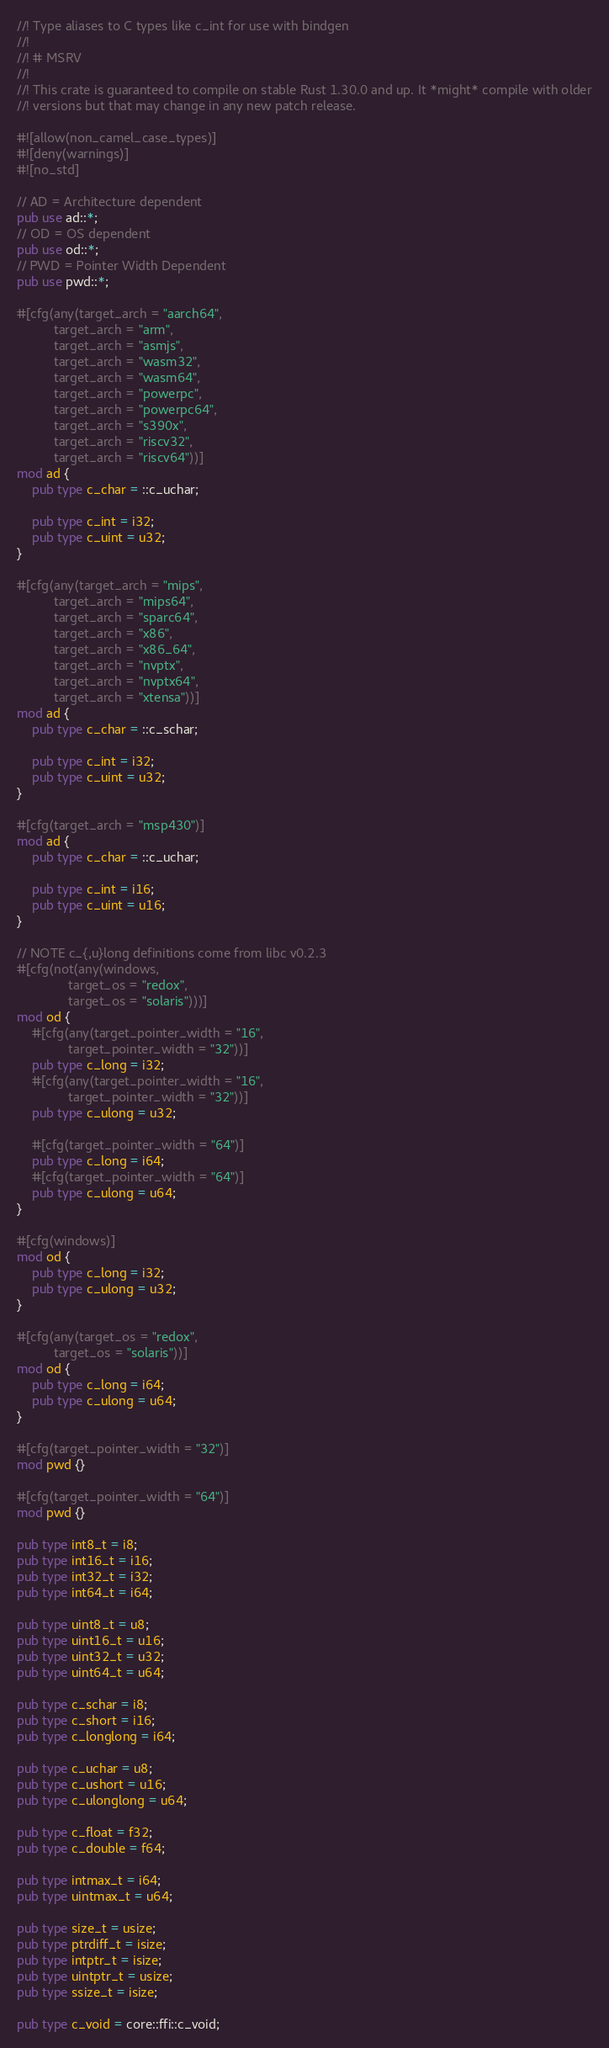Convert code to text. <code><loc_0><loc_0><loc_500><loc_500><_Rust_>//! Type aliases to C types like c_int for use with bindgen
//!
//! # MSRV
//!
//! This crate is guaranteed to compile on stable Rust 1.30.0 and up. It *might* compile with older
//! versions but that may change in any new patch release.

#![allow(non_camel_case_types)]
#![deny(warnings)]
#![no_std]

// AD = Architecture dependent
pub use ad::*;
// OD = OS dependent
pub use od::*;
// PWD = Pointer Width Dependent
pub use pwd::*;

#[cfg(any(target_arch = "aarch64",
          target_arch = "arm",
          target_arch = "asmjs",
          target_arch = "wasm32",
          target_arch = "wasm64",
          target_arch = "powerpc",
          target_arch = "powerpc64",
          target_arch = "s390x",
          target_arch = "riscv32",
          target_arch = "riscv64"))]
mod ad {
    pub type c_char = ::c_uchar;

    pub type c_int = i32;
    pub type c_uint = u32;
}

#[cfg(any(target_arch = "mips",
          target_arch = "mips64",
          target_arch = "sparc64",
          target_arch = "x86",
          target_arch = "x86_64",
          target_arch = "nvptx",
          target_arch = "nvptx64",
          target_arch = "xtensa"))]
mod ad {
    pub type c_char = ::c_schar;

    pub type c_int = i32;
    pub type c_uint = u32;
}

#[cfg(target_arch = "msp430")]
mod ad {
    pub type c_char = ::c_uchar;

    pub type c_int = i16;
    pub type c_uint = u16;
}

// NOTE c_{,u}long definitions come from libc v0.2.3
#[cfg(not(any(windows,
              target_os = "redox",
              target_os = "solaris")))]
mod od {
    #[cfg(any(target_pointer_width = "16",
              target_pointer_width = "32"))]
    pub type c_long = i32;
    #[cfg(any(target_pointer_width = "16",
              target_pointer_width = "32"))]
    pub type c_ulong = u32;

    #[cfg(target_pointer_width = "64")]
    pub type c_long = i64;
    #[cfg(target_pointer_width = "64")]
    pub type c_ulong = u64;
}

#[cfg(windows)]
mod od {
    pub type c_long = i32;
    pub type c_ulong = u32;
}

#[cfg(any(target_os = "redox",
          target_os = "solaris"))]
mod od {
    pub type c_long = i64;
    pub type c_ulong = u64;
}

#[cfg(target_pointer_width = "32")]
mod pwd {}

#[cfg(target_pointer_width = "64")]
mod pwd {}

pub type int8_t = i8;
pub type int16_t = i16;
pub type int32_t = i32;
pub type int64_t = i64;

pub type uint8_t = u8;
pub type uint16_t = u16;
pub type uint32_t = u32;
pub type uint64_t = u64;

pub type c_schar = i8;
pub type c_short = i16;
pub type c_longlong = i64;

pub type c_uchar = u8;
pub type c_ushort = u16;
pub type c_ulonglong = u64;

pub type c_float = f32;
pub type c_double = f64;

pub type intmax_t = i64;
pub type uintmax_t = u64;

pub type size_t = usize;
pub type ptrdiff_t = isize;
pub type intptr_t = isize;
pub type uintptr_t = usize;
pub type ssize_t = isize;

pub type c_void = core::ffi::c_void;
</code> 